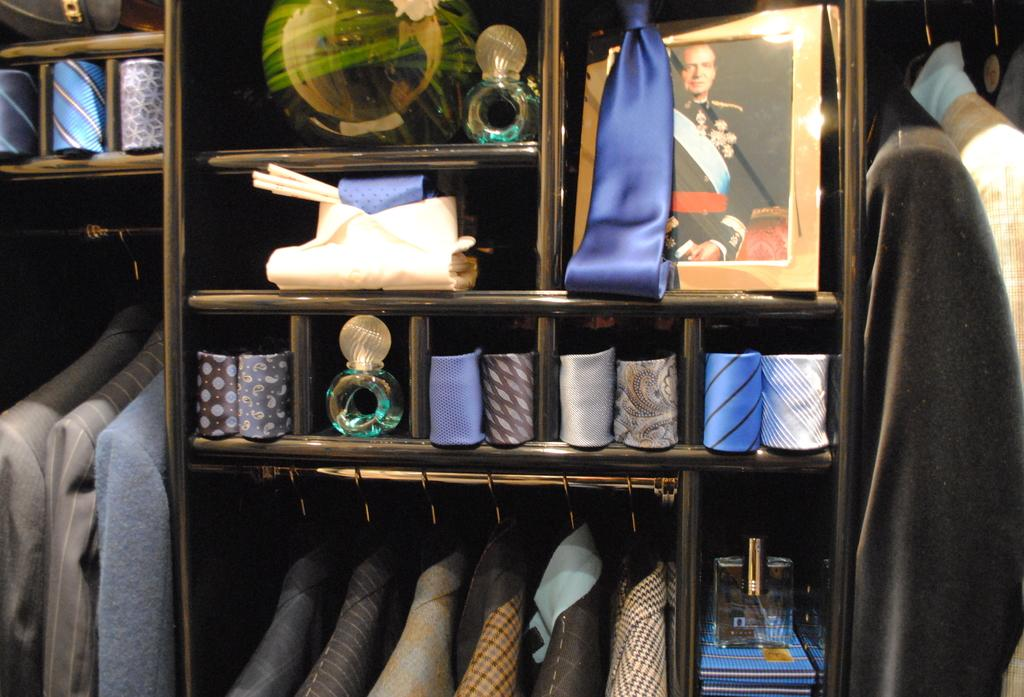What is the main object in the center of the image? There is a rack in the center of the image. What is the purpose of the rack? The rack is used for holding clothes. How many babies are sitting on the hill in the image? There are no babies or hills present in the image; it only features a rack with clothes. 